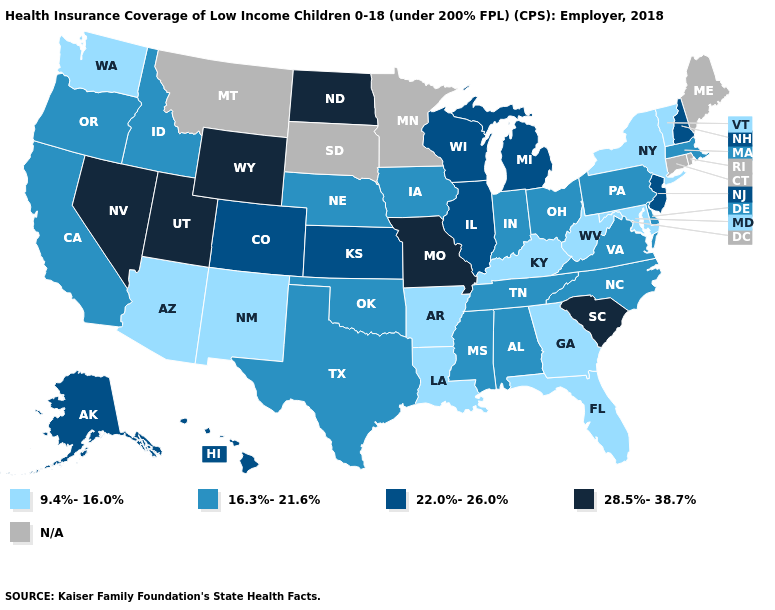Does North Dakota have the highest value in the MidWest?
Quick response, please. Yes. Which states have the highest value in the USA?
Quick response, please. Missouri, Nevada, North Dakota, South Carolina, Utah, Wyoming. Does the first symbol in the legend represent the smallest category?
Write a very short answer. Yes. Name the states that have a value in the range 9.4%-16.0%?
Write a very short answer. Arizona, Arkansas, Florida, Georgia, Kentucky, Louisiana, Maryland, New Mexico, New York, Vermont, Washington, West Virginia. What is the value of South Carolina?
Quick response, please. 28.5%-38.7%. Does the map have missing data?
Short answer required. Yes. What is the lowest value in the USA?
Quick response, please. 9.4%-16.0%. Is the legend a continuous bar?
Write a very short answer. No. Does Georgia have the lowest value in the South?
Keep it brief. Yes. What is the value of Minnesota?
Keep it brief. N/A. Which states have the highest value in the USA?
Quick response, please. Missouri, Nevada, North Dakota, South Carolina, Utah, Wyoming. What is the value of Kentucky?
Keep it brief. 9.4%-16.0%. What is the lowest value in the West?
Concise answer only. 9.4%-16.0%. Does North Carolina have the lowest value in the USA?
Concise answer only. No. 